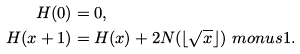<formula> <loc_0><loc_0><loc_500><loc_500>H ( 0 ) & = 0 , \\ H ( x + 1 ) & = H ( x ) + 2 N ( \lfloor \sqrt { x } \rfloor ) \ m o n u s 1 .</formula> 